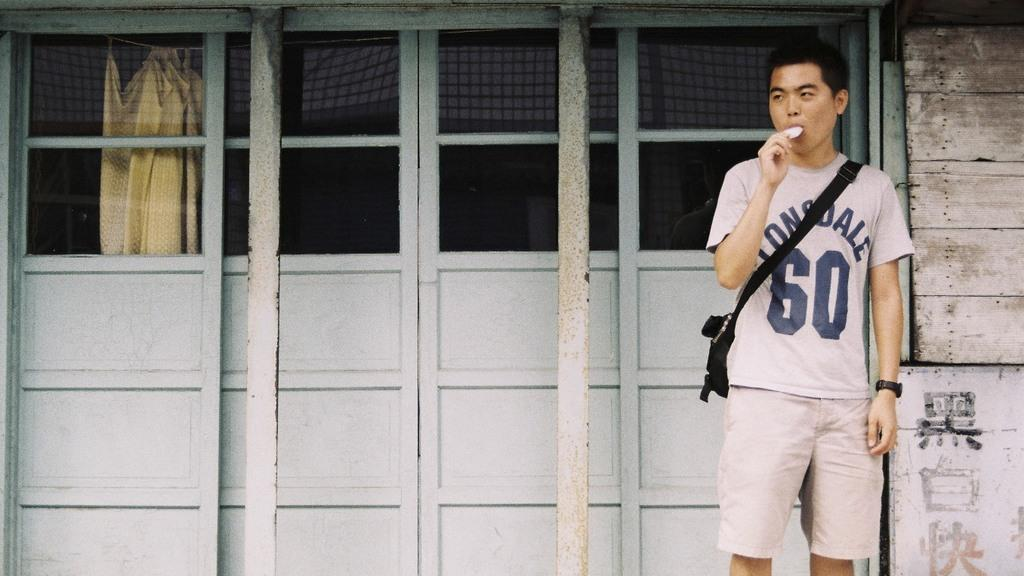<image>
Give a short and clear explanation of the subsequent image. A boy  standing in front of a door with a t shirt  that has the number 60 on top. 